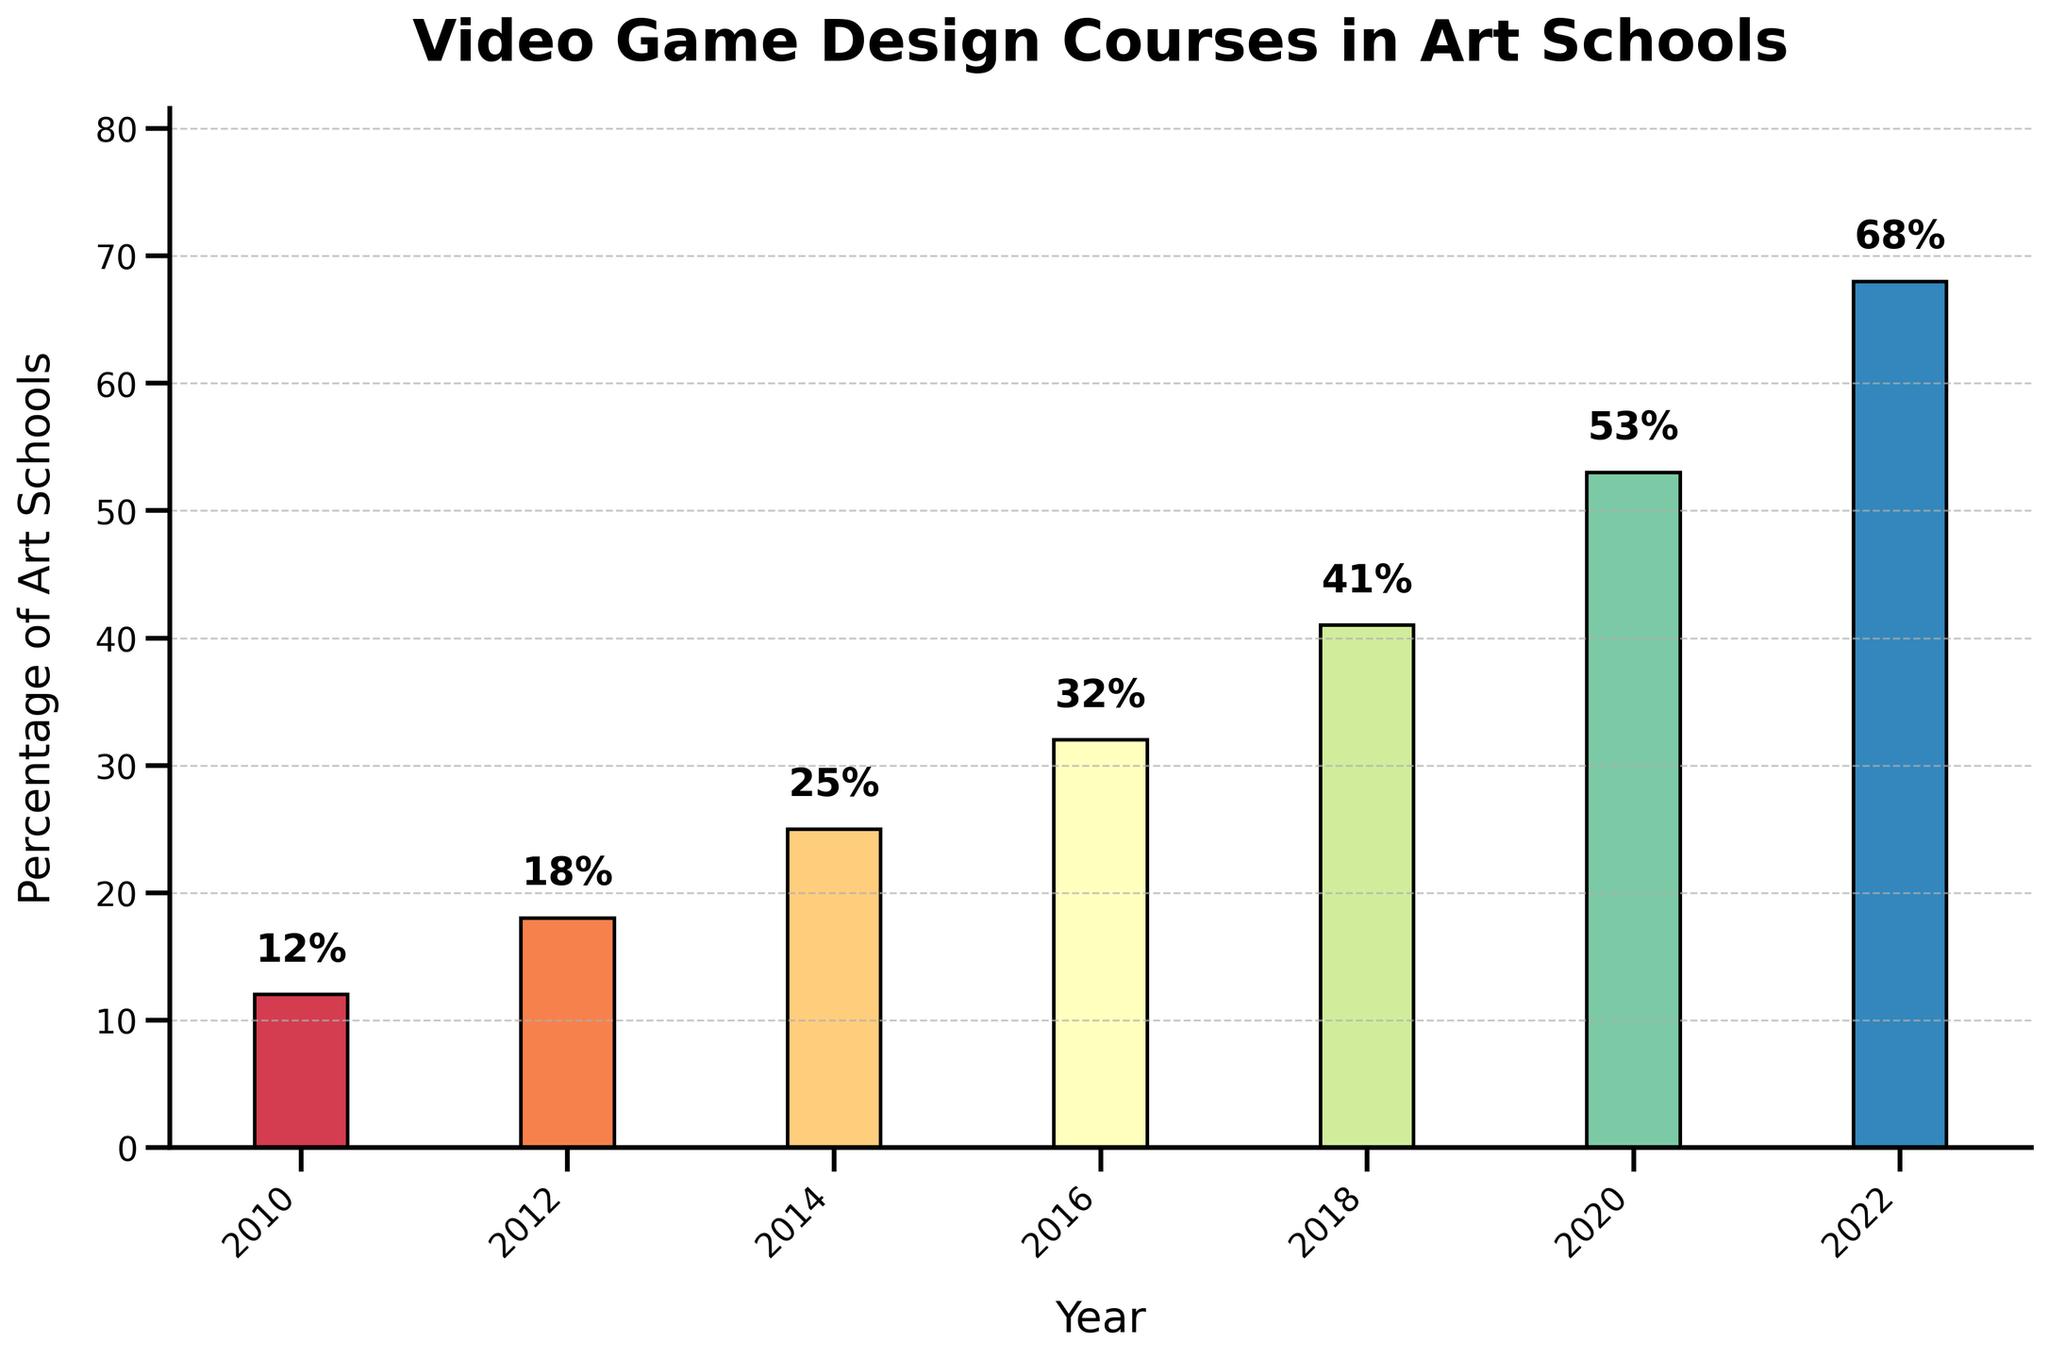What is the percentage of art schools offering courses in video game design and development in 2014? The percentage is shown on the bar corresponding to the year 2014. The bar reaches up to 25%.
Answer: 25% Which year shows the greatest increase in percentage from the previous year? Comparing the differences between consecutive years: (2012-2010 = 6%), (2014-2012 = 7%), (2016-2014 = 7%), (2018-2016 = 9%), (2020-2018 = 12%), (2022-2020 = 15%). The greatest increase is between 2020 and 2022 by 15%.
Answer: 2022 How many years are recorded on the chart? Count the x-axis labels. The bars represent data points from 2010, 2012, 2014, 2016, 2018, 2020, and 2022, totaling 7 years.
Answer: 7 years What is the average percentage of art schools offering courses in video game design and development across all years? To find the average percentage: Add all percentages (12 + 18 + 25 + 32 + 41 + 53 + 68) = 249, then divide by the number of years (249/7 ≈ 35.57%).
Answer: 35.57% Compare the percentage increase from 2012 to 2014 with the increase from 2010 to 2012. What is the difference between these two increases? Calculate the difference for each span: (2014-2012) = 7%, (2012-2010) = 6%. The difference between the two increases is 7% - 6% = 1%.
Answer: 1% Which year has the highest percentage of art schools offering courses in video game design and development, and what is that percentage? Look for the tallest bar. The year with the highest percentage is 2022, showing 68%.
Answer: 2022 and 68% What is the range of the percentages shown in the bar chart? The range is the difference between the maximum and minimum values on the y-axis. The highest percentage is 68%, and the lowest is 12%. So, the range is 68% - 12% = 56%.
Answer: 56% By how much did the percentage increase from 2018 to 2020? The bar for 2018 shows 41%, and the bar for 2020 shows 53%. The increase is 53% - 41% = 12%.
Answer: 12% Are there any years where the percentage increase remained constant compared to the previous years? Examining the percentage increases between consecutive years: (6%, 7%, 7%, 9%, 12%, 15%). There are two spans with the same increase (7% from 2012 to 2014 and 7% from 2014 to 2016).
Answer: Yes, from 2012 to 2016 What visual element is used to emphasize the different years on the bar chart? The bars are colored differently, with a gradient spectrum ensuring each bar representing a year is distinct.
Answer: Different colors 